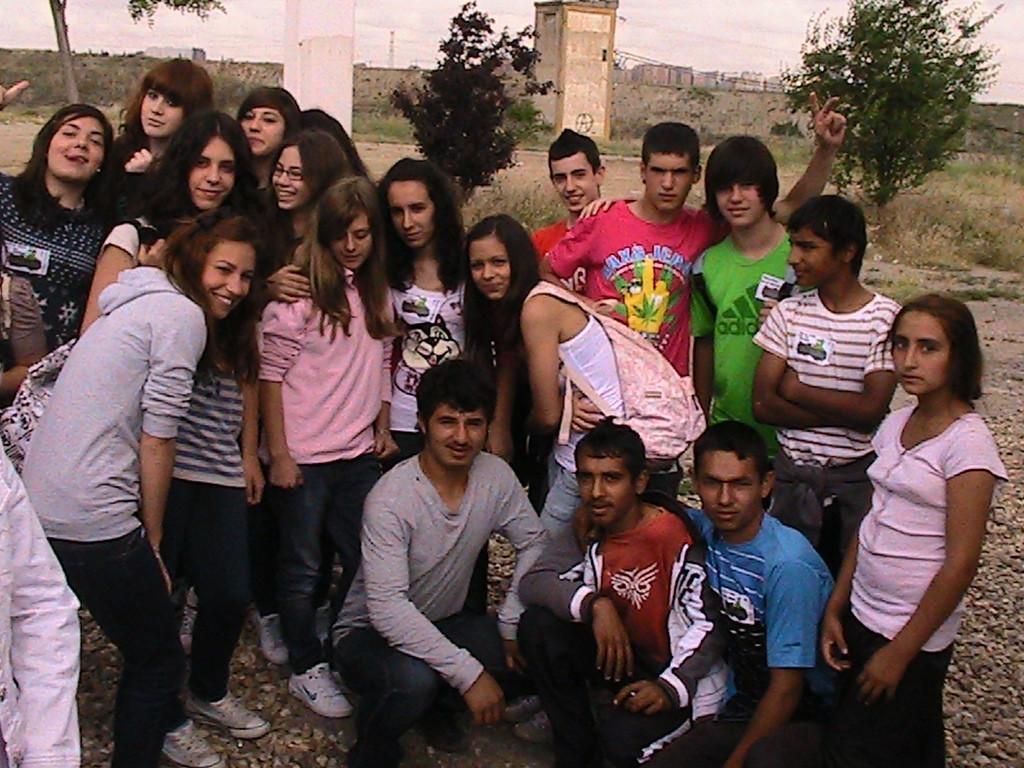Describe this image in one or two sentences. In this image we can see people. In the background of the image there is wall. There are buildings, sky, trees. 